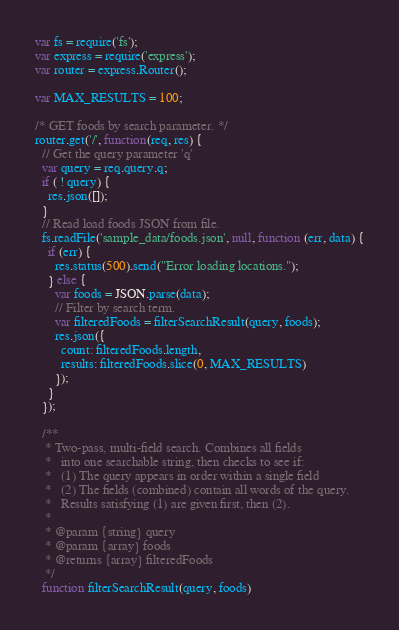Convert code to text. <code><loc_0><loc_0><loc_500><loc_500><_JavaScript_>var fs = require('fs');
var express = require('express');
var router = express.Router();

var MAX_RESULTS = 100;

/* GET foods by search parameter. */
router.get('/', function(req, res) {
  // Get the query parameter 'q'
  var query = req.query.q;
  if ( ! query) {
    res.json([]);
  }
  // Read load foods JSON from file.
  fs.readFile('sample_data/foods.json', null, function (err, data) {
    if (err) {
      res.status(500).send("Error loading locations.");
    } else {
      var foods = JSON.parse(data);
      // Filter by search term.
      var filteredFoods = filterSearchResult(query, foods);
      res.json({
        count: filteredFoods.length,
        results: filteredFoods.slice(0, MAX_RESULTS)
      });
    }
  });

  /**
   * Two-pass, multi-field search. Combines all fields
   *   into one searchable string, then checks to see if:
   *   (1) The query appears in order within a single field
   *   (2) The fields (combined) contain all words of the query.
   *   Results satisfying (1) are given first, then (2).
   *
   * @param {string} query
   * @param {array} foods
   * @returns {array} filteredFoods
   */
  function filterSearchResult(query, foods)</code> 